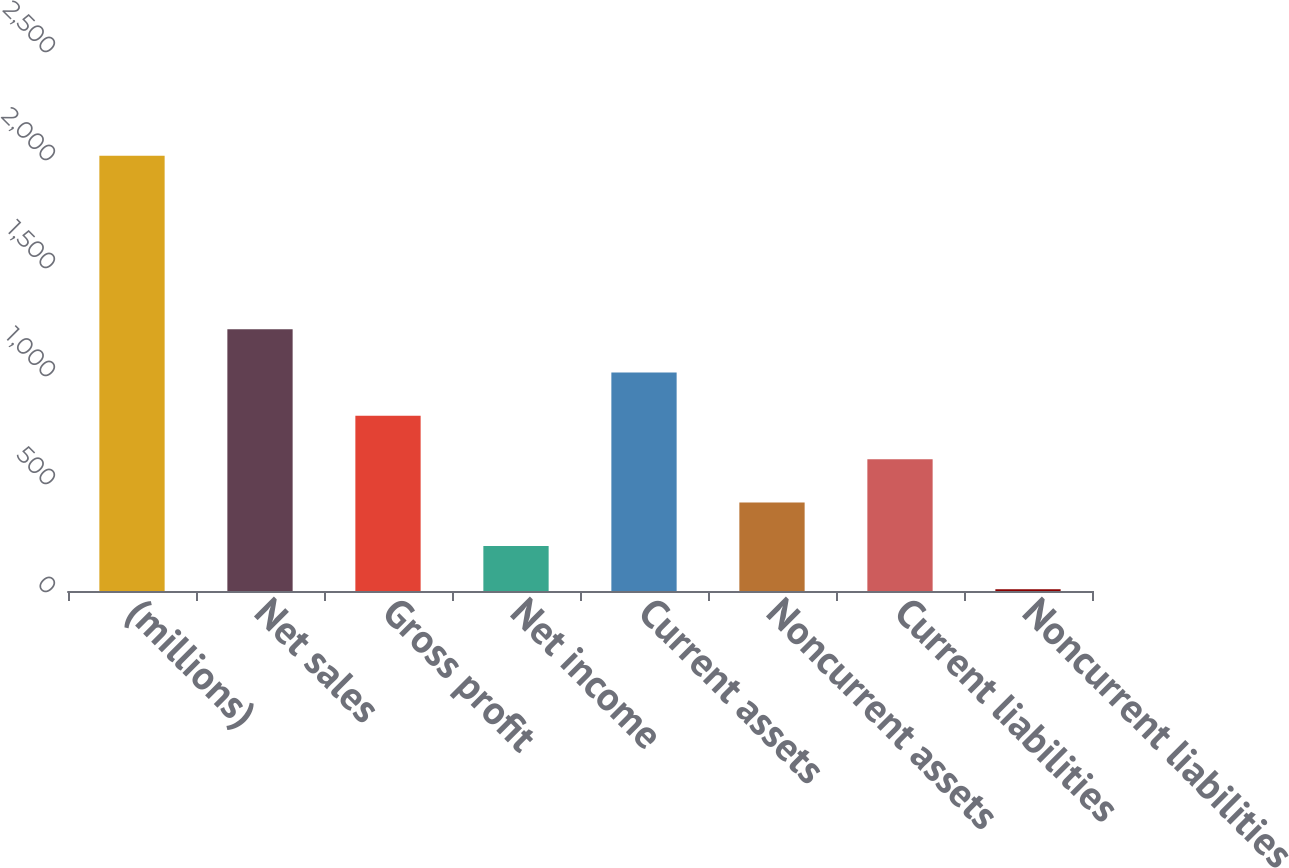Convert chart. <chart><loc_0><loc_0><loc_500><loc_500><bar_chart><fcel>(millions)<fcel>Net sales<fcel>Gross profit<fcel>Net income<fcel>Current assets<fcel>Noncurrent assets<fcel>Current liabilities<fcel>Noncurrent liabilities<nl><fcel>2015<fcel>1212.24<fcel>810.86<fcel>208.79<fcel>1011.55<fcel>409.48<fcel>610.17<fcel>8.1<nl></chart> 